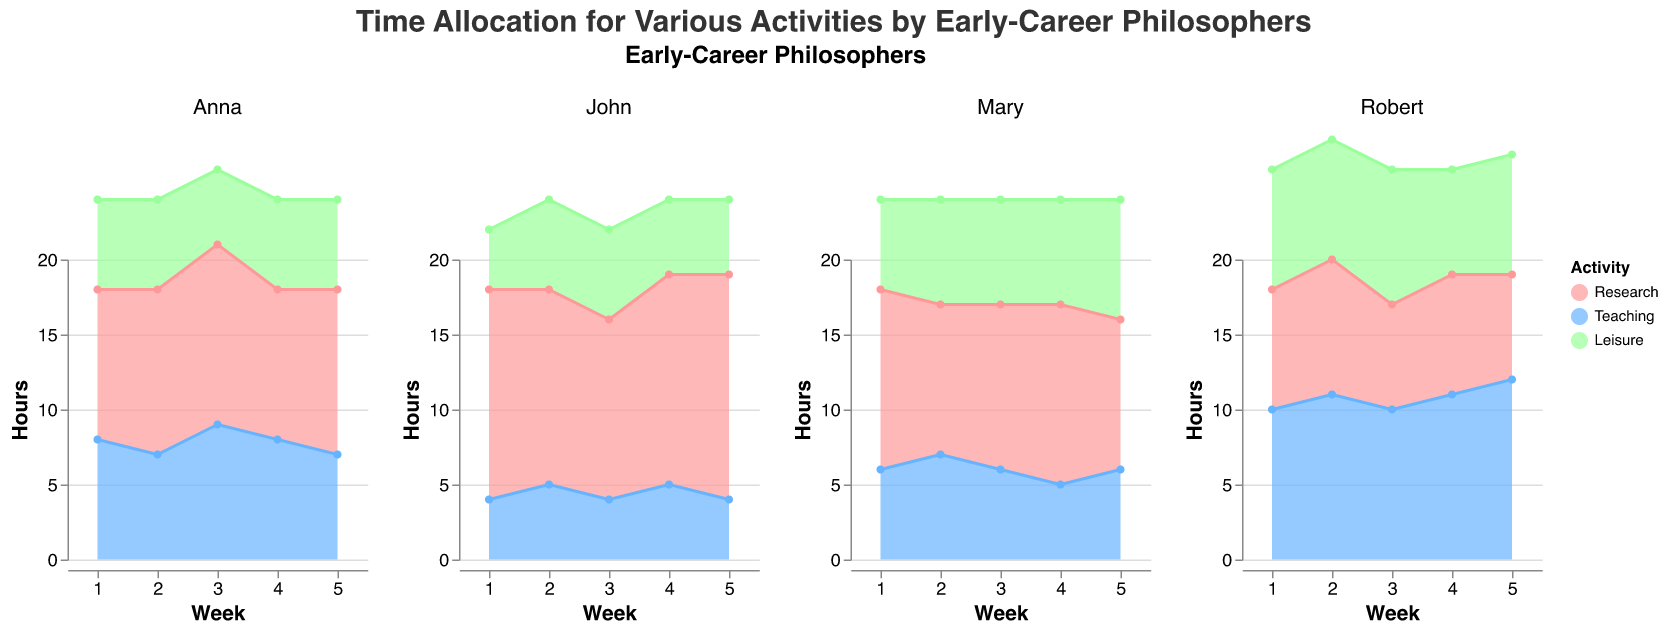How many hours did Mary spend on research in Week 1? Look at Mary's subplot, find the Week 1 data point, and identify the value for Research.
Answer: 12 Which activity did John spend the most time on in Week 2? In John's subplot, look at the Week 2 data points and compare the hours spent on Research, Teaching, and Leisure.
Answer: Research What is the total time Anna spent on Teaching across all weeks? Look at Anna's subplot. Sum the hours spent on Teaching from Weeks 1 to 5: 8 + 7 + 9 + 8 + 7 = 39.
Answer: 39 How does Robert's time allocation for Leisure change from Week 1 to Week 5? Observe the trend in Robert's subplot for Leisure from Week 1 to Week 5: 8, 8, 9, 7, 8.
Answer: Slight fluctuation, but relatively stable Who spent the most time on Teaching in Week 4, and how many hours? Compare the hours spent on Teaching in Week 4 across all subplots: 5 (Mary), 5 (John), 8 (Anna), and 11 (Robert).
Answer: Robert, 11 hours Between Week 2 and Week 3, who increased their research hours the most and by how much? Calculate the difference in Research hours between Week 2 and Week 3 for each person: Mary (1), John (-1), Anna (1), Robert (-2). Mary and Anna increased by 1 hour each.
Answer: Mary and Anna, 1 hour Which activity is the most consistent in terms of hours spent by Anna throughout the weeks? Look at Anna's subplots and compare the hours spent on each activity over the weeks. Research: 10, 11, 12, 10, 11. Teaching: 8, 7, 9, 8, 7. Leisure: 6, 6, 5, 6, 6.
Answer: Leisure What is the average number of hours John spent on Leisure over the five weeks? Calculate the average of John's Leisure hours from Week 1 to Week 5: (4 + 6 + 6 + 5 + 5) / 5 = 5.2.
Answer: 5.2 